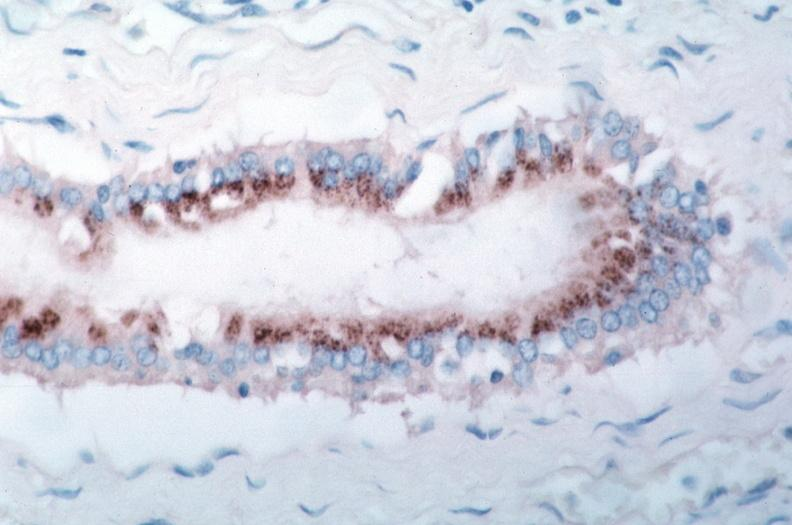what is rocky mountain spotted?
Answer the question using a single word or phrase. Fever 